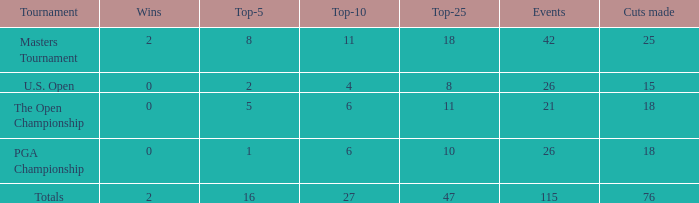What are the largest slashes made when the incidents are fewer than 21? None. 